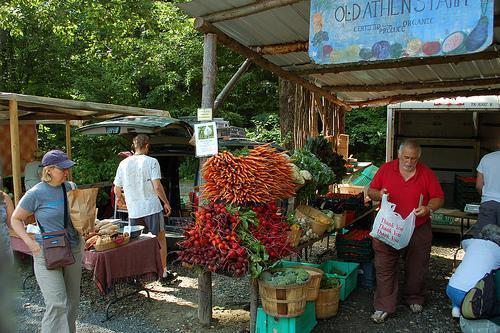How many people do you see in this picture?
Give a very brief answer. 5. How many white shirts are in this picture?
Give a very brief answer. 3. 